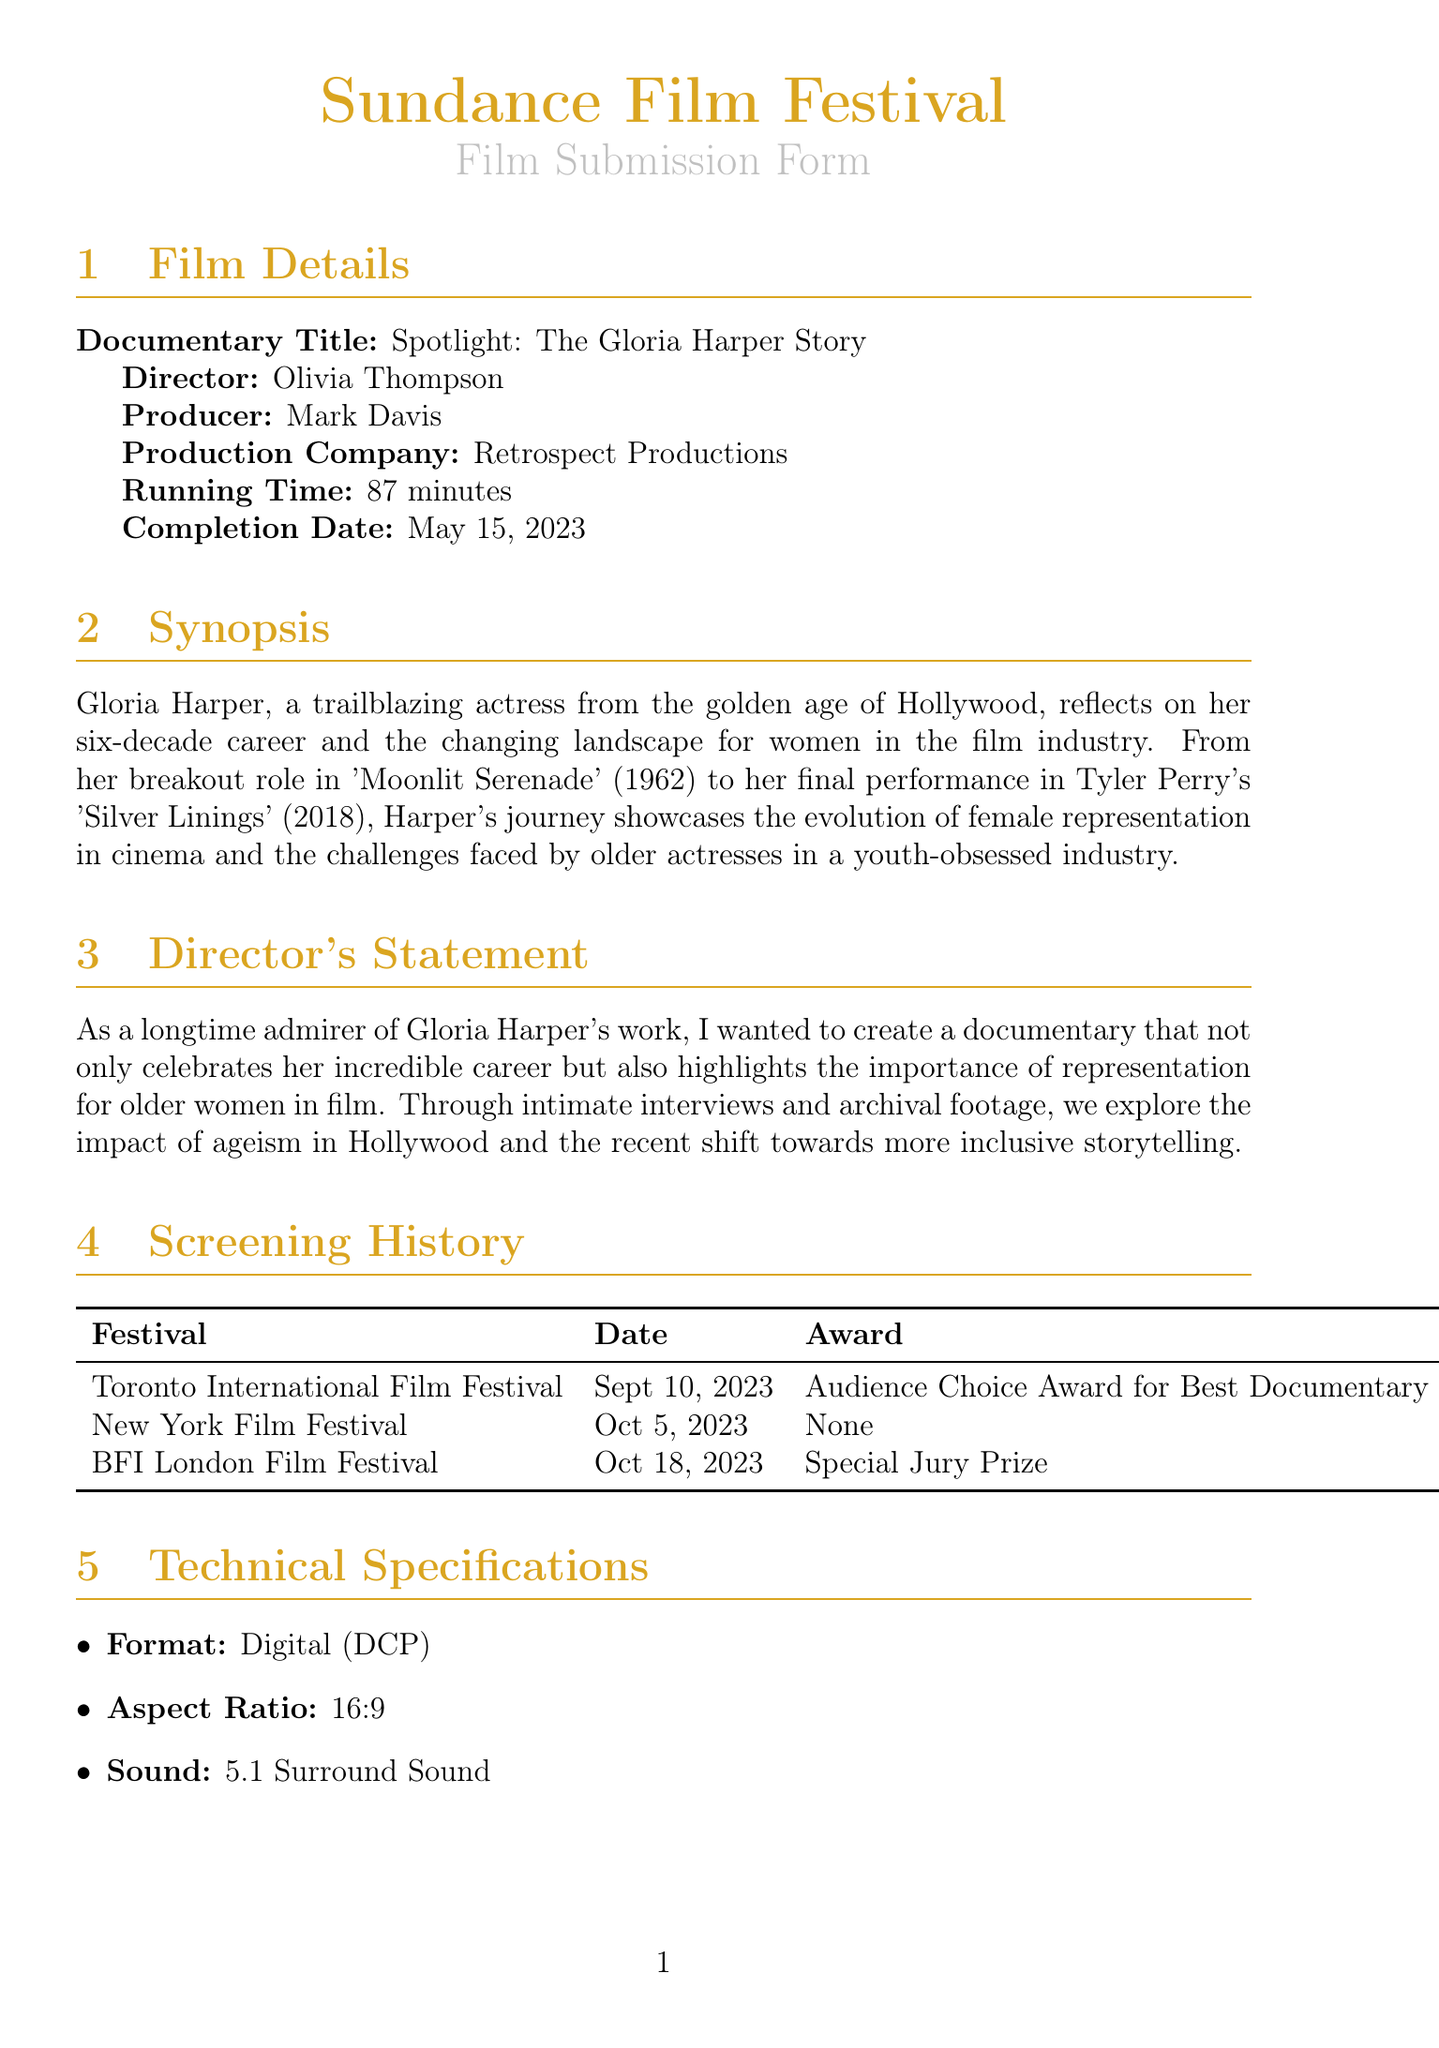What is the title of the documentary? The title is provided in the Film Details section, specifically labeled 'Documentary Title'.
Answer: Spotlight: The Gloria Harper Story Who directed the documentary? The director's name can be found in the Film Details section under 'Director'.
Answer: Olivia Thompson What award did the documentary win at the Toronto International Film Festival? The award is listed in the Screening History section, alongside the festival date.
Answer: Audience Choice Award for Best Documentary What is the running time of the documentary? The running time is specified in the Film Details section under 'Running Time'.
Answer: 87 minutes What special consideration is requested for the screening venues? This information is specified in the Special Considerations section, mentioning needs due to Gloria Harper's age.
Answer: Accessible screening venues What format is the documentary presented in? The format is included in the Technical Specifications section, labeled 'Format'.
Answer: Digital (DCP) How many high-resolution stills are included in the marketing materials? The number of stills is detailed in the Marketing Materials section.
Answer: 5 High-Resolution Stills Who is the producer of the documentary? The producer's name is indicated in the Film Details section under 'Producer'.
Answer: Mark Davis What is the aspect ratio of the documentary? The aspect ratio is specified in the Technical Specifications section under 'Aspect Ratio'.
Answer: 16:9 